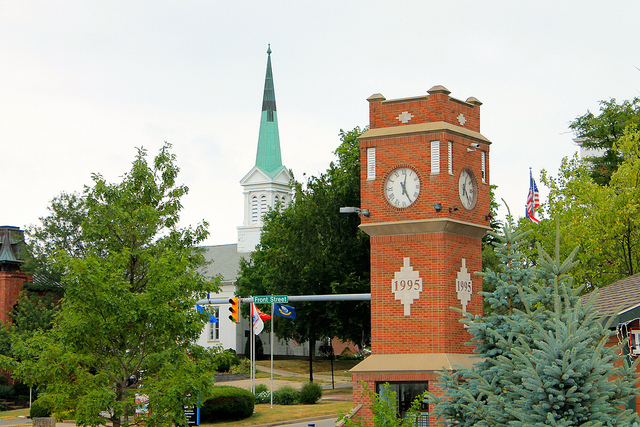<image>What is the name of that road? I don't know the name of the road. It can be 'ferrell', 'pearl', 'stairway road', 'brook pines', 'prince street', '1995' or 'main street'. What is the name of that road? I am not aware of the name of that road. It can be Ferrell, Pearl, Stairway Road, Brook Pines, Prince Street, 1995, Main Street or Road. 